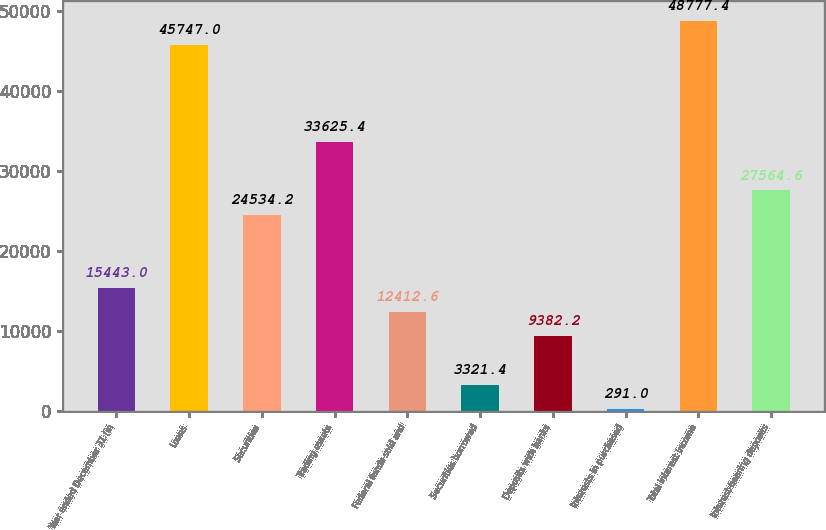Convert chart. <chart><loc_0><loc_0><loc_500><loc_500><bar_chart><fcel>Year ended December 31 (in<fcel>Loans<fcel>Securities<fcel>Trading assets<fcel>Federal funds sold and<fcel>Securities borrowed<fcel>Deposits with banks<fcel>Interests in purchased<fcel>Total interest income<fcel>Interest-bearing deposits<nl><fcel>15443<fcel>45747<fcel>24534.2<fcel>33625.4<fcel>12412.6<fcel>3321.4<fcel>9382.2<fcel>291<fcel>48777.4<fcel>27564.6<nl></chart> 